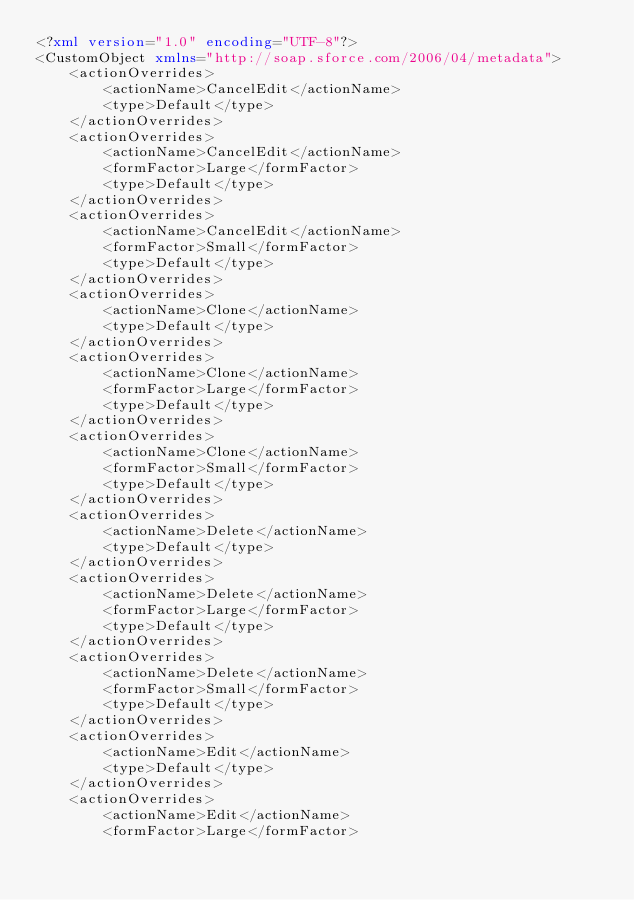<code> <loc_0><loc_0><loc_500><loc_500><_XML_><?xml version="1.0" encoding="UTF-8"?>
<CustomObject xmlns="http://soap.sforce.com/2006/04/metadata">
    <actionOverrides>
        <actionName>CancelEdit</actionName>
        <type>Default</type>
    </actionOverrides>
    <actionOverrides>
        <actionName>CancelEdit</actionName>
        <formFactor>Large</formFactor>
        <type>Default</type>
    </actionOverrides>
    <actionOverrides>
        <actionName>CancelEdit</actionName>
        <formFactor>Small</formFactor>
        <type>Default</type>
    </actionOverrides>
    <actionOverrides>
        <actionName>Clone</actionName>
        <type>Default</type>
    </actionOverrides>
    <actionOverrides>
        <actionName>Clone</actionName>
        <formFactor>Large</formFactor>
        <type>Default</type>
    </actionOverrides>
    <actionOverrides>
        <actionName>Clone</actionName>
        <formFactor>Small</formFactor>
        <type>Default</type>
    </actionOverrides>
    <actionOverrides>
        <actionName>Delete</actionName>
        <type>Default</type>
    </actionOverrides>
    <actionOverrides>
        <actionName>Delete</actionName>
        <formFactor>Large</formFactor>
        <type>Default</type>
    </actionOverrides>
    <actionOverrides>
        <actionName>Delete</actionName>
        <formFactor>Small</formFactor>
        <type>Default</type>
    </actionOverrides>
    <actionOverrides>
        <actionName>Edit</actionName>
        <type>Default</type>
    </actionOverrides>
    <actionOverrides>
        <actionName>Edit</actionName>
        <formFactor>Large</formFactor></code> 